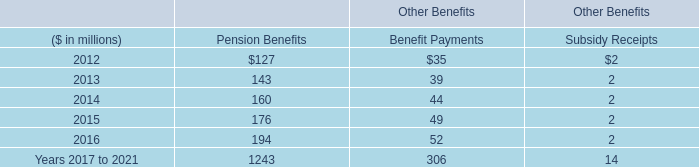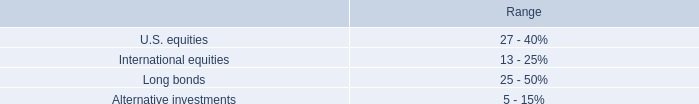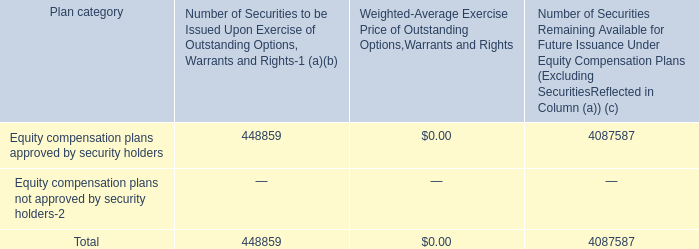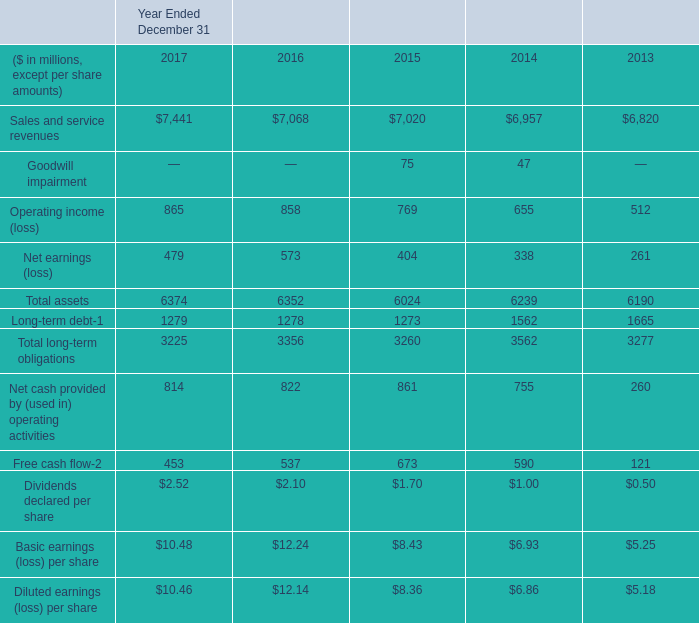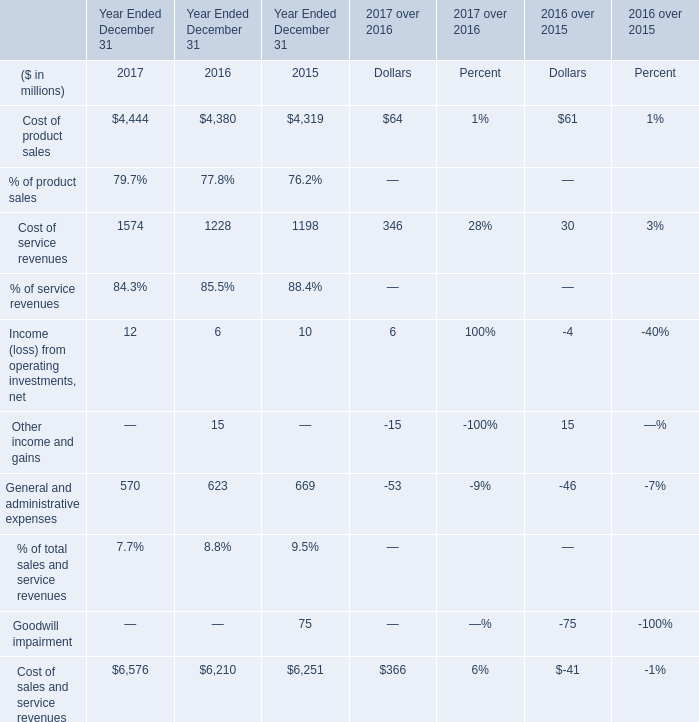In the year with largest amount of Cost of product sales, what's the sum of Cost of service revenues and General and administrative expenses ? (in million) 
Computations: (1574 + 570)
Answer: 2144.0. 